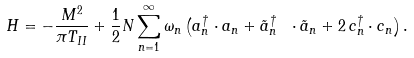<formula> <loc_0><loc_0><loc_500><loc_500>H = - \frac { M ^ { 2 } } { \pi T _ { I I } } + \frac { 1 } { 2 } N \sum _ { n = 1 } ^ { \infty } \omega _ { n } \left ( a _ { n } ^ { \dagger } \cdot a _ { n } + \tilde { a } _ { n } ^ { \dagger } \ \cdot \tilde { a } _ { n } + 2 \, c _ { n } ^ { \dagger } \cdot c _ { n } \right ) .</formula> 